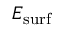Convert formula to latex. <formula><loc_0><loc_0><loc_500><loc_500>E _ { s u r f }</formula> 